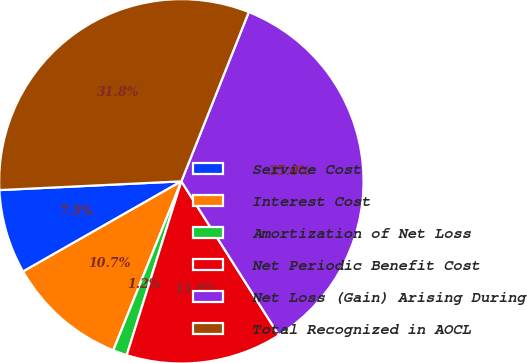Convert chart to OTSL. <chart><loc_0><loc_0><loc_500><loc_500><pie_chart><fcel>Service Cost<fcel>Interest Cost<fcel>Amortization of Net Loss<fcel>Net Periodic Benefit Cost<fcel>Net Loss (Gain) Arising During<fcel>Total Recognized in AOCL<nl><fcel>7.48%<fcel>10.66%<fcel>1.25%<fcel>13.84%<fcel>34.98%<fcel>31.8%<nl></chart> 